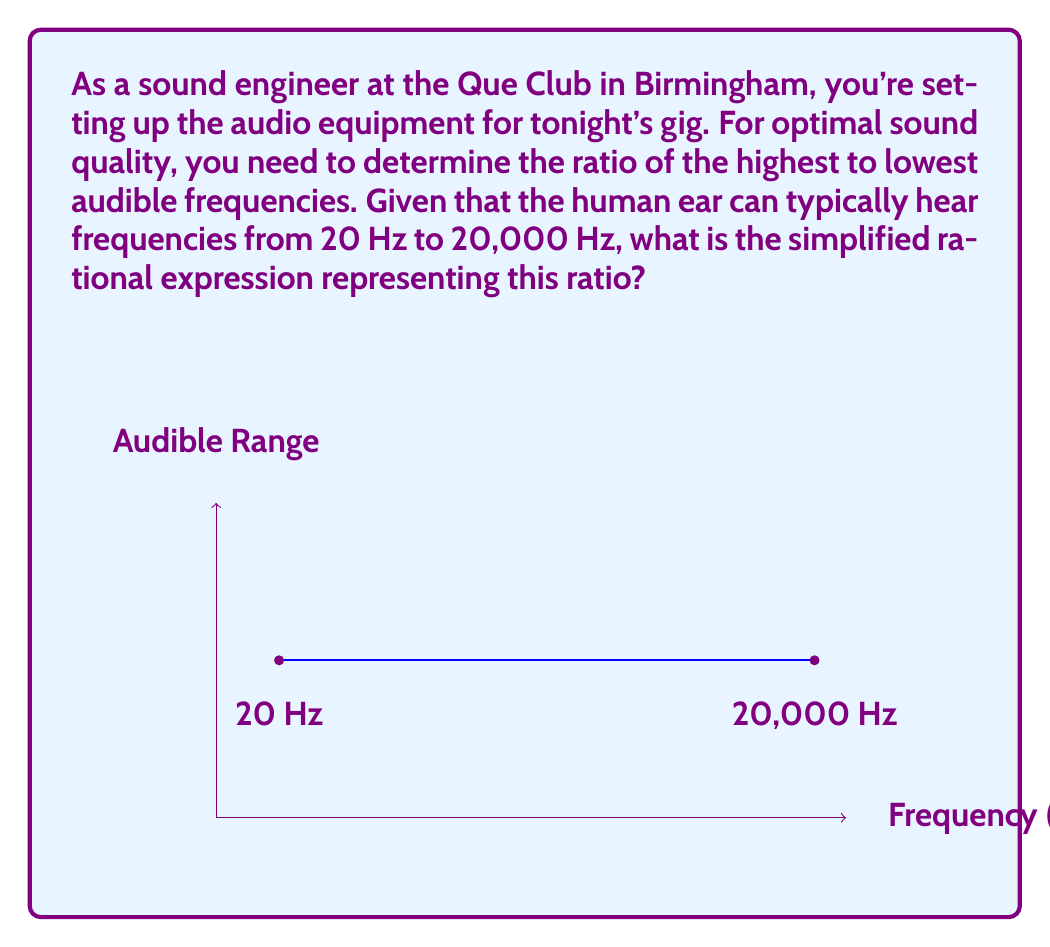Can you answer this question? Let's approach this step-by-step:

1) We're looking for the ratio of the highest to lowest audible frequencies.

2) Highest audible frequency = 20,000 Hz
   Lowest audible frequency = 20 Hz

3) The ratio can be expressed as a fraction:

   $$\frac{\text{Highest frequency}}{\text{Lowest frequency}} = \frac{20,000}{20}$$

4) To simplify this rational expression, we need to find the greatest common divisor (GCD) of the numerator and denominator:

   $GCD(20,000, 20) = 20$

5) Divide both the numerator and denominator by the GCD:

   $$\frac{20,000 \div 20}{20 \div 20} = \frac{1,000}{1}$$

6) The simplified rational expression is 1000:1

This ratio indicates that the highest audible frequency is 1000 times the lowest audible frequency, which is a crucial consideration when setting up audio equipment to cover the full range of human hearing.
Answer: 1000:1 